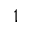<formula> <loc_0><loc_0><loc_500><loc_500>^ { 1 }</formula> 